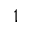<formula> <loc_0><loc_0><loc_500><loc_500>^ { 1 }</formula> 